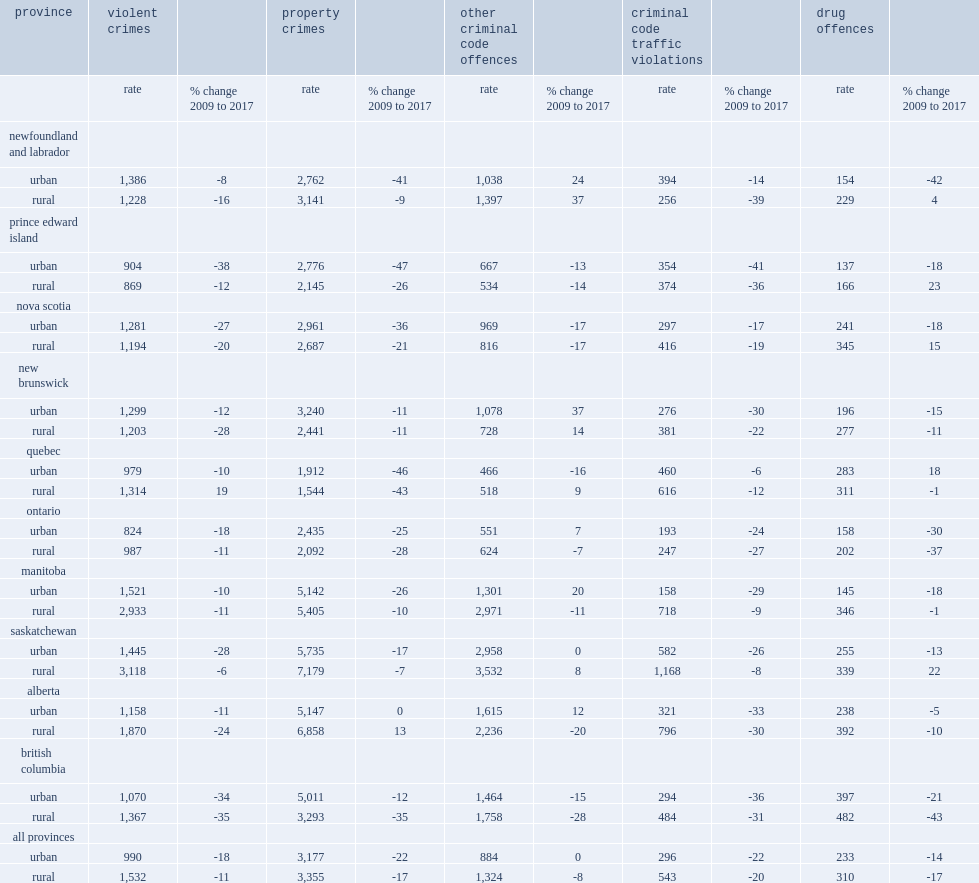What were the changes for property crime in alberta and other criminal code offences in newfoundland and labrador and new brunswick from 2009 to 2017? 13.0 37.0 14.0. 